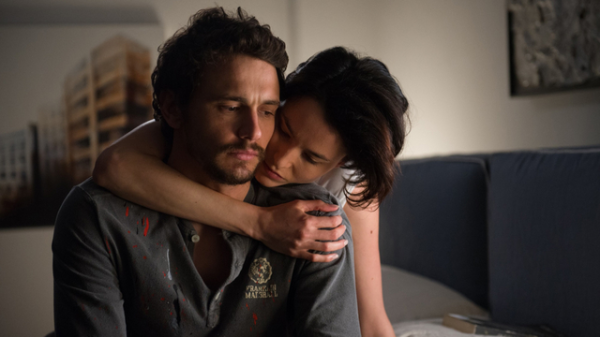What emotions does this image evoke, and what might be the reason behind these emotions? The image evokes emotions of tenderness, concern, and fatigue. The man's weary expression and the spatter on his shirt suggest he might have been through a stressful or dangerous situation, possibly related to his role indicated by the marshal badge. The woman's gentle kiss and the way she cradles his face convey care and affection, likely aiming to comfort him after his ordeal. Can you discuss the significance of the setting in this scene? The setting, a dimly lit room with a plain yet cozy appearance, plays a crucial role in highlighting the intimacy of the moment. The darkness of the room contributes to a feeling of isolation from the outside world, focusing on the emotional exchange between the two individuals. The simplicity of the decor, including the plain walls and minimalistic furniture, suggests that the scene could be taking place in a safe house or a personal residence, emphasizing privacy and seclusion. 